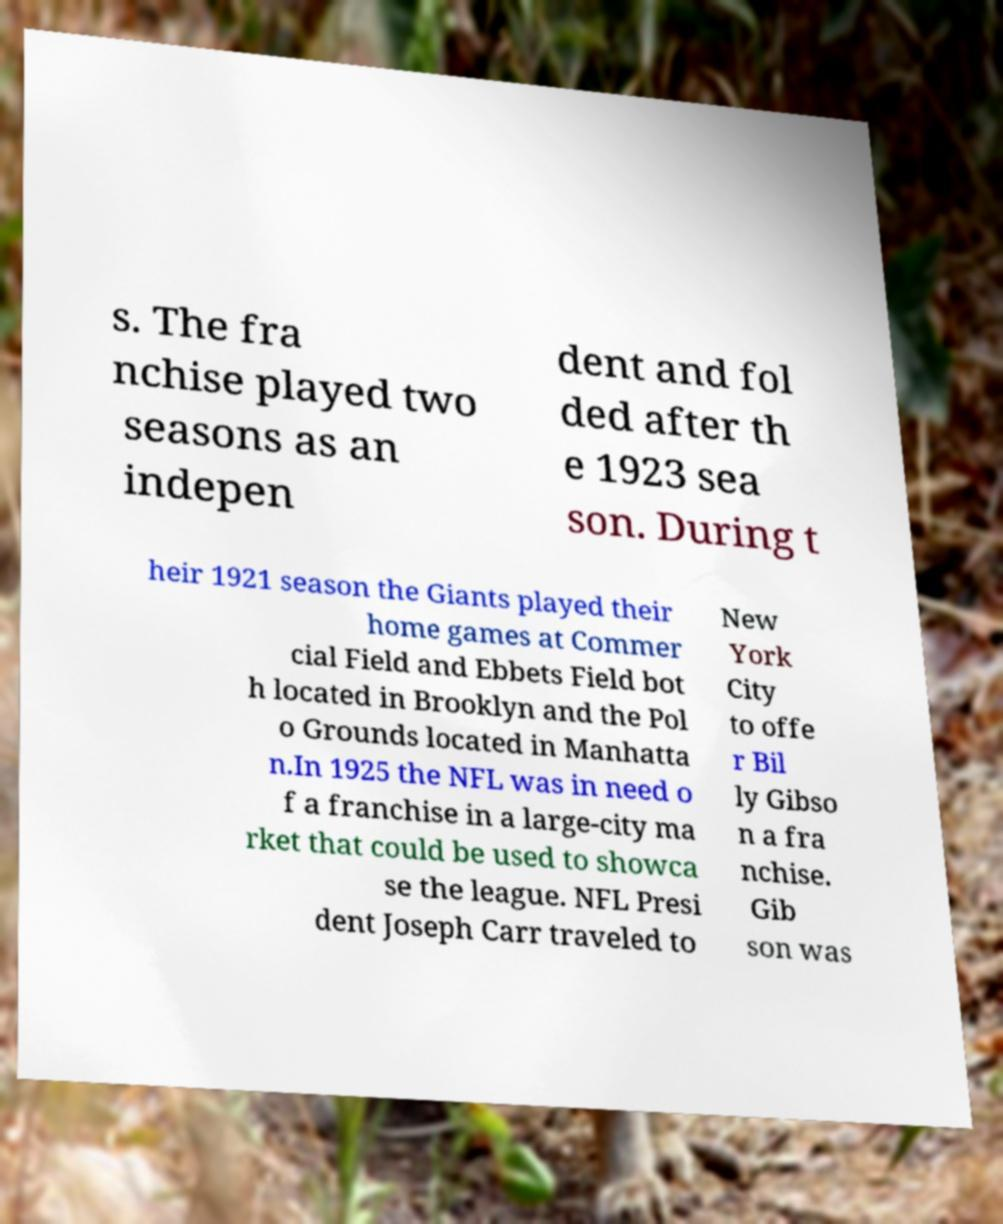Could you extract and type out the text from this image? s. The fra nchise played two seasons as an indepen dent and fol ded after th e 1923 sea son. During t heir 1921 season the Giants played their home games at Commer cial Field and Ebbets Field bot h located in Brooklyn and the Pol o Grounds located in Manhatta n.In 1925 the NFL was in need o f a franchise in a large-city ma rket that could be used to showca se the league. NFL Presi dent Joseph Carr traveled to New York City to offe r Bil ly Gibso n a fra nchise. Gib son was 